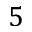<formula> <loc_0><loc_0><loc_500><loc_500>5</formula> 